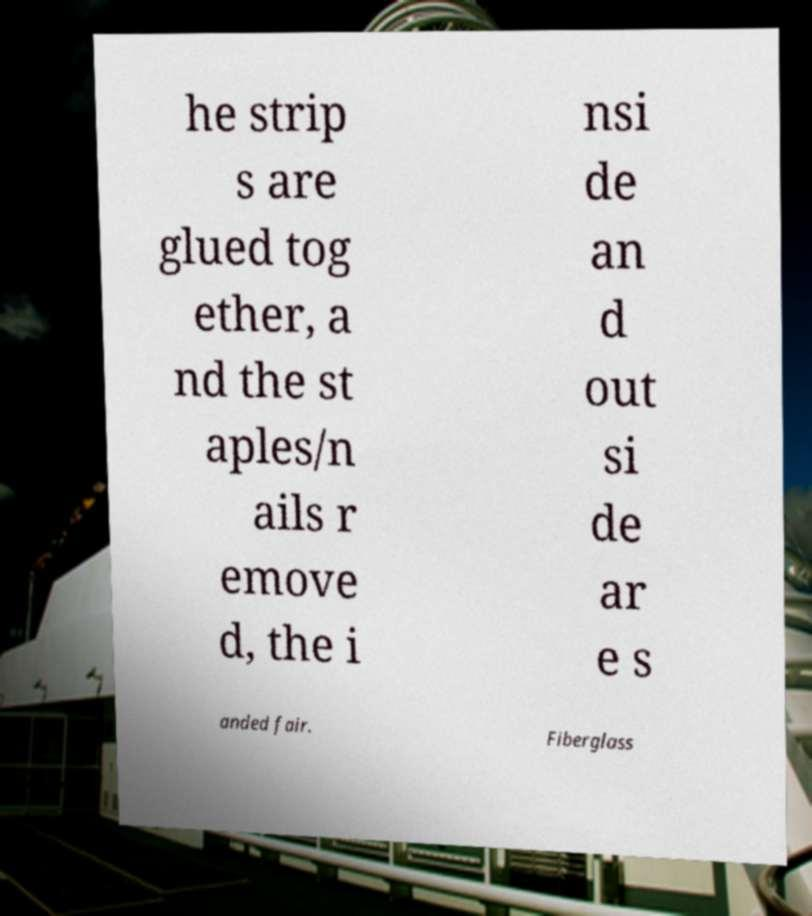Could you extract and type out the text from this image? he strip s are glued tog ether, a nd the st aples/n ails r emove d, the i nsi de an d out si de ar e s anded fair. Fiberglass 